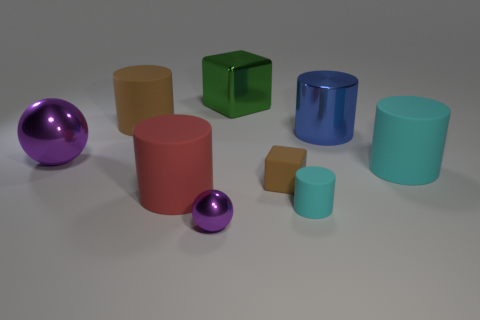How many big shiny things are on the right side of the red matte object and on the left side of the blue cylinder?
Your response must be concise. 1. There is a red object; is its size the same as the purple ball that is in front of the small cube?
Make the answer very short. No. There is a purple metal object that is behind the cube to the right of the big green metal thing; is there a large ball behind it?
Provide a short and direct response. No. There is a ball behind the cyan cylinder to the left of the blue cylinder; what is it made of?
Offer a terse response. Metal. What is the object that is left of the large red rubber object and to the right of the big sphere made of?
Offer a terse response. Rubber. Are there any big green objects that have the same shape as the red thing?
Ensure brevity in your answer.  No. Is there a tiny cyan rubber object that is on the right side of the cyan rubber thing in front of the big red matte cylinder?
Provide a short and direct response. No. How many large gray objects have the same material as the large green object?
Ensure brevity in your answer.  0. Is there a purple metal cylinder?
Ensure brevity in your answer.  No. How many rubber objects are the same color as the small rubber cylinder?
Your response must be concise. 1. 